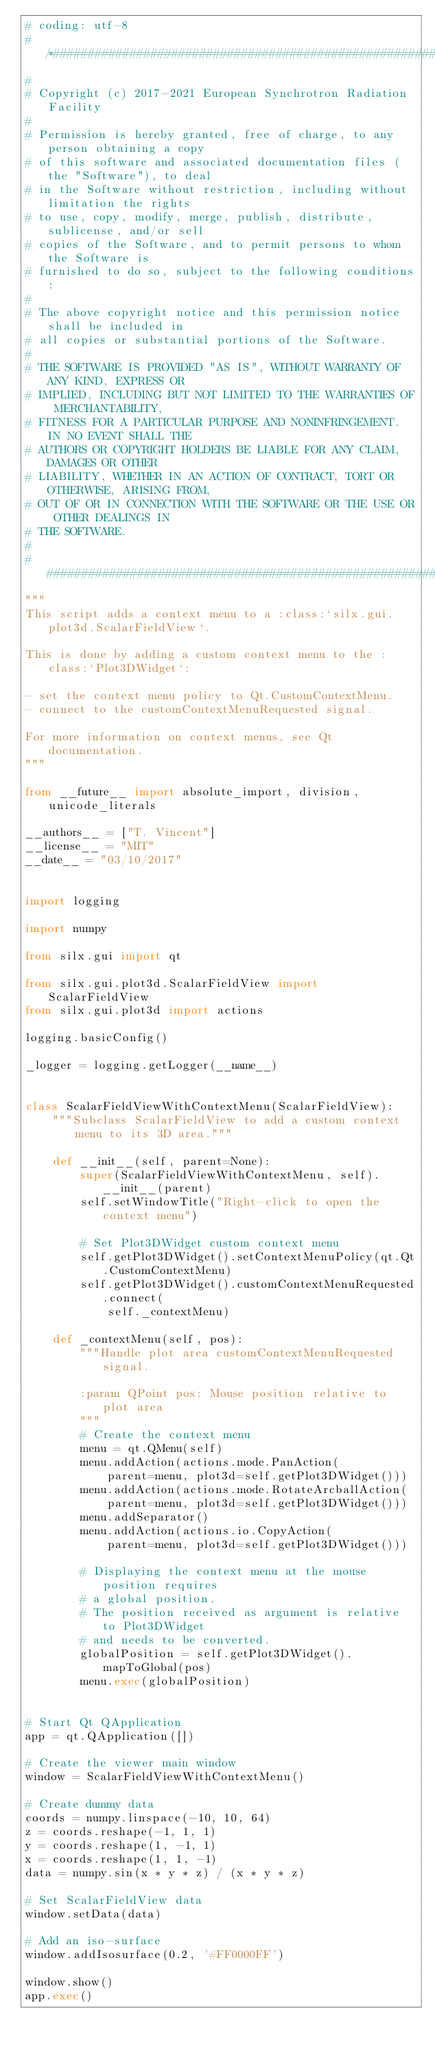<code> <loc_0><loc_0><loc_500><loc_500><_Python_># coding: utf-8
# /*##########################################################################
#
# Copyright (c) 2017-2021 European Synchrotron Radiation Facility
#
# Permission is hereby granted, free of charge, to any person obtaining a copy
# of this software and associated documentation files (the "Software"), to deal
# in the Software without restriction, including without limitation the rights
# to use, copy, modify, merge, publish, distribute, sublicense, and/or sell
# copies of the Software, and to permit persons to whom the Software is
# furnished to do so, subject to the following conditions:
#
# The above copyright notice and this permission notice shall be included in
# all copies or substantial portions of the Software.
#
# THE SOFTWARE IS PROVIDED "AS IS", WITHOUT WARRANTY OF ANY KIND, EXPRESS OR
# IMPLIED, INCLUDING BUT NOT LIMITED TO THE WARRANTIES OF MERCHANTABILITY,
# FITNESS FOR A PARTICULAR PURPOSE AND NONINFRINGEMENT. IN NO EVENT SHALL THE
# AUTHORS OR COPYRIGHT HOLDERS BE LIABLE FOR ANY CLAIM, DAMAGES OR OTHER
# LIABILITY, WHETHER IN AN ACTION OF CONTRACT, TORT OR OTHERWISE, ARISING FROM,
# OUT OF OR IN CONNECTION WITH THE SOFTWARE OR THE USE OR OTHER DEALINGS IN
# THE SOFTWARE.
#
# ###########################################################################*/
"""
This script adds a context menu to a :class:`silx.gui.plot3d.ScalarFieldView`.

This is done by adding a custom context menu to the :class:`Plot3DWidget`:

- set the context menu policy to Qt.CustomContextMenu.
- connect to the customContextMenuRequested signal.

For more information on context menus, see Qt documentation.
"""

from __future__ import absolute_import, division, unicode_literals

__authors__ = ["T. Vincent"]
__license__ = "MIT"
__date__ = "03/10/2017"


import logging

import numpy

from silx.gui import qt

from silx.gui.plot3d.ScalarFieldView import ScalarFieldView
from silx.gui.plot3d import actions

logging.basicConfig()

_logger = logging.getLogger(__name__)


class ScalarFieldViewWithContextMenu(ScalarFieldView):
    """Subclass ScalarFieldView to add a custom context menu to its 3D area."""

    def __init__(self, parent=None):
        super(ScalarFieldViewWithContextMenu, self).__init__(parent)
        self.setWindowTitle("Right-click to open the context menu")

        # Set Plot3DWidget custom context menu
        self.getPlot3DWidget().setContextMenuPolicy(qt.Qt.CustomContextMenu)
        self.getPlot3DWidget().customContextMenuRequested.connect(
            self._contextMenu)

    def _contextMenu(self, pos):
        """Handle plot area customContextMenuRequested signal.

        :param QPoint pos: Mouse position relative to plot area
        """
        # Create the context menu
        menu = qt.QMenu(self)
        menu.addAction(actions.mode.PanAction(
            parent=menu, plot3d=self.getPlot3DWidget()))
        menu.addAction(actions.mode.RotateArcballAction(
            parent=menu, plot3d=self.getPlot3DWidget()))
        menu.addSeparator()
        menu.addAction(actions.io.CopyAction(
            parent=menu, plot3d=self.getPlot3DWidget()))

        # Displaying the context menu at the mouse position requires
        # a global position.
        # The position received as argument is relative to Plot3DWidget
        # and needs to be converted.
        globalPosition = self.getPlot3DWidget().mapToGlobal(pos)
        menu.exec(globalPosition)


# Start Qt QApplication
app = qt.QApplication([])

# Create the viewer main window
window = ScalarFieldViewWithContextMenu()

# Create dummy data
coords = numpy.linspace(-10, 10, 64)
z = coords.reshape(-1, 1, 1)
y = coords.reshape(1, -1, 1)
x = coords.reshape(1, 1, -1)
data = numpy.sin(x * y * z) / (x * y * z)

# Set ScalarFieldView data
window.setData(data)

# Add an iso-surface
window.addIsosurface(0.2, '#FF0000FF')

window.show()
app.exec()
</code> 